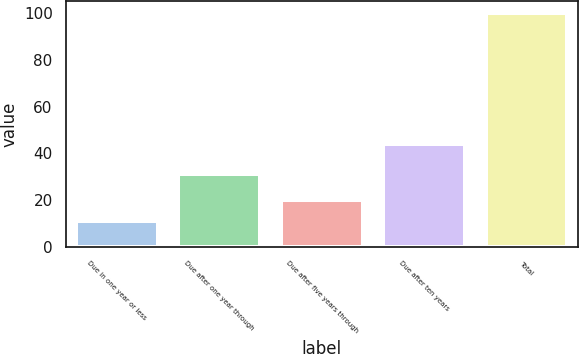Convert chart to OTSL. <chart><loc_0><loc_0><loc_500><loc_500><bar_chart><fcel>Due in one year or less<fcel>Due after one year through<fcel>Due after five years through<fcel>Due after ten years<fcel>Total<nl><fcel>11<fcel>31<fcel>19.9<fcel>44<fcel>100<nl></chart> 